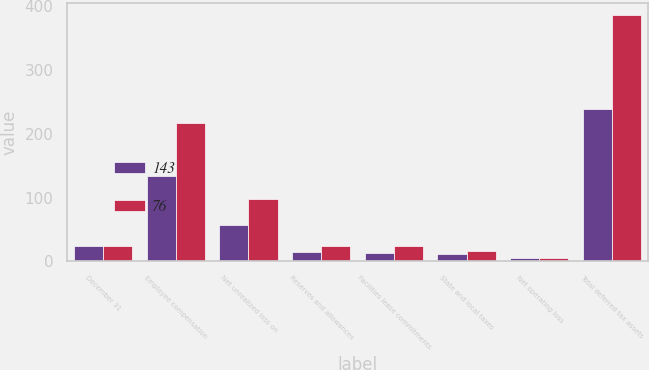Convert chart. <chart><loc_0><loc_0><loc_500><loc_500><stacked_bar_chart><ecel><fcel>December 31<fcel>Employee compensation<fcel>Net unrealized loss on<fcel>Reserves and allowances<fcel>Facilities lease commitments<fcel>State and local taxes<fcel>Net operating loss<fcel>Total deferred tax assets<nl><fcel>143<fcel>25<fcel>133<fcel>57<fcel>15<fcel>14<fcel>12<fcel>5<fcel>239<nl><fcel>76<fcel>25<fcel>216<fcel>97<fcel>25<fcel>25<fcel>17<fcel>5<fcel>385<nl></chart> 